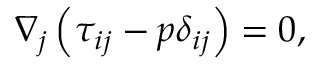<formula> <loc_0><loc_0><loc_500><loc_500>\nabla _ { j } \left ( \tau _ { i j } - p \delta _ { i j } \right ) = 0 ,</formula> 